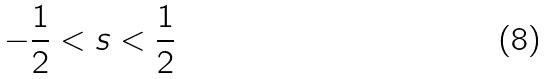<formula> <loc_0><loc_0><loc_500><loc_500>- \frac { 1 } { 2 } < s < \frac { 1 } { 2 }</formula> 